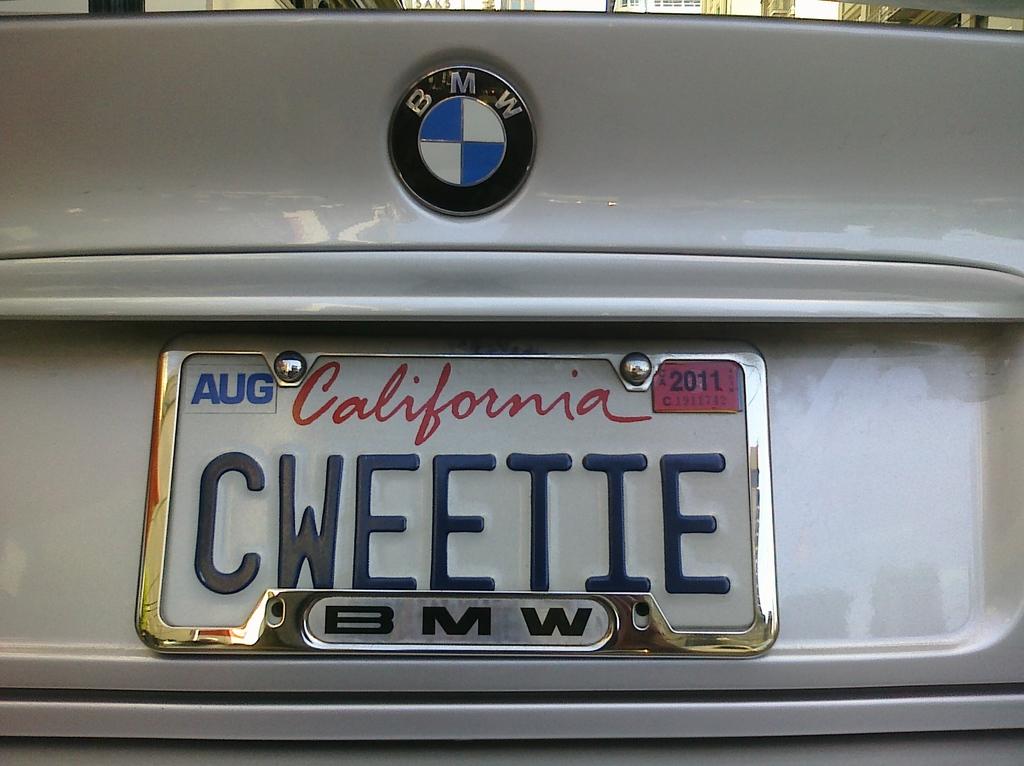Why type of car is this?
Keep it short and to the point. Bmw. What state is the license plate from?
Your answer should be compact. California. 